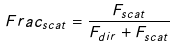Convert formula to latex. <formula><loc_0><loc_0><loc_500><loc_500>F r a c _ { s c a t } = \frac { F _ { s c a t } } { F _ { d i r } + F _ { s c a t } }</formula> 